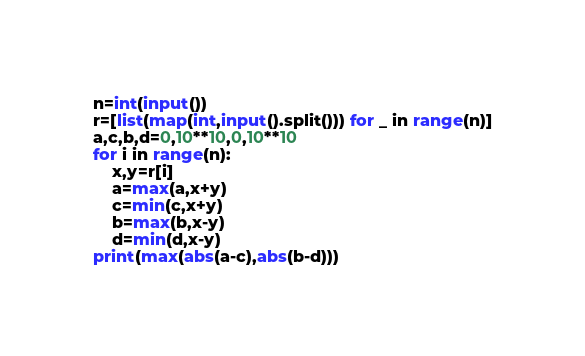Convert code to text. <code><loc_0><loc_0><loc_500><loc_500><_Python_>n=int(input())
r=[list(map(int,input().split())) for _ in range(n)]
a,c,b,d=0,10**10,0,10**10
for i in range(n):
    x,y=r[i]
    a=max(a,x+y)
    c=min(c,x+y)
    b=max(b,x-y)
    d=min(d,x-y)
print(max(abs(a-c),abs(b-d)))</code> 